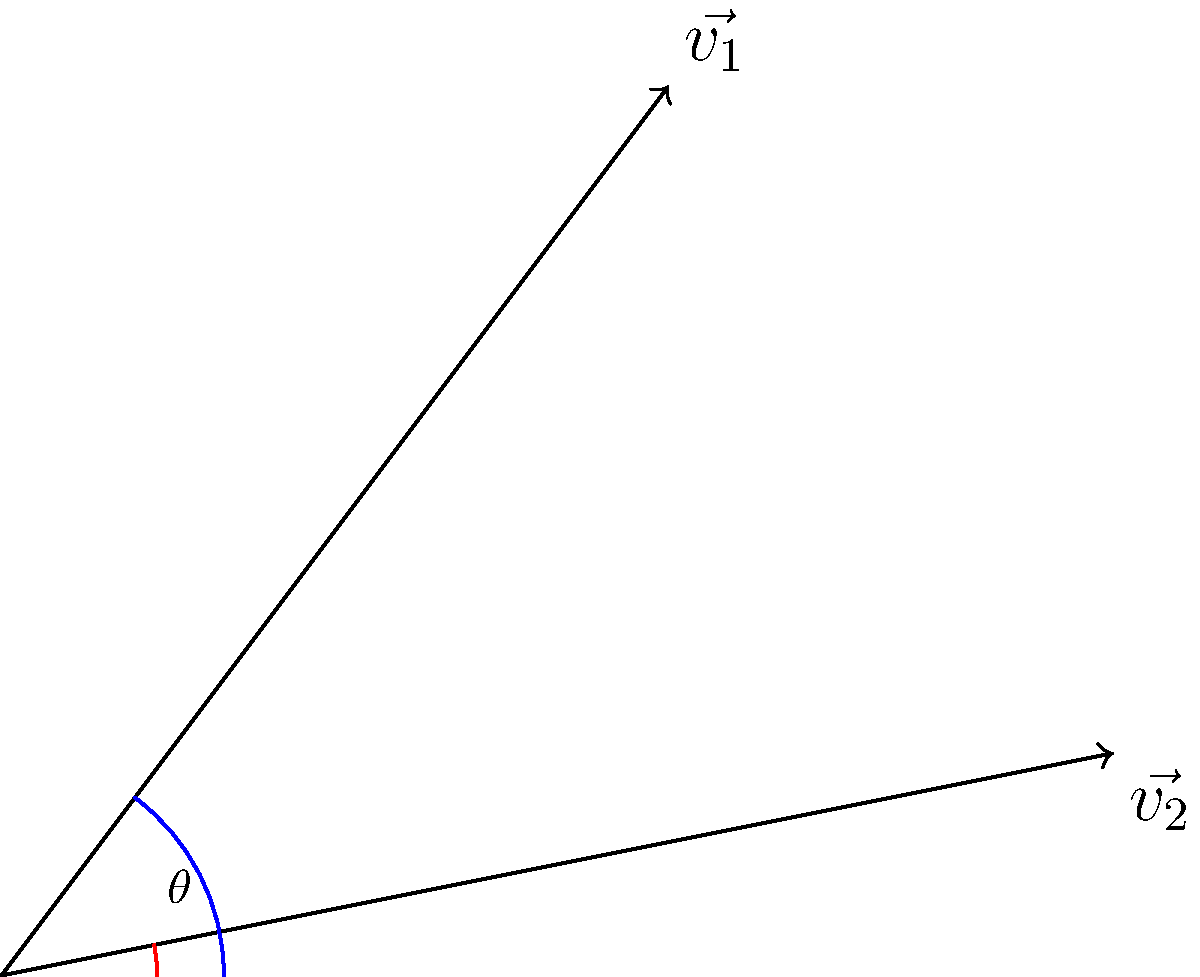Given two velocity vectors $\vec{v_1} = (3, 4)$ and $\vec{v_2} = (5, 1)$ in a 2D plane, determine the angle $\theta$ between them. Express your answer in degrees, rounded to the nearest whole number. To find the angle between two vectors, we can use the dot product formula:

1) The dot product formula: $\cos \theta = \frac{\vec{v_1} \cdot \vec{v_2}}{|\vec{v_1}||\vec{v_2}|}$

2) Calculate the dot product:
   $\vec{v_1} \cdot \vec{v_2} = (3 \times 5) + (4 \times 1) = 15 + 4 = 19$

3) Calculate the magnitudes:
   $|\vec{v_1}| = \sqrt{3^2 + 4^2} = \sqrt{9 + 16} = \sqrt{25} = 5$
   $|\vec{v_2}| = \sqrt{5^2 + 1^2} = \sqrt{25 + 1} = \sqrt{26}$

4) Substitute into the formula:
   $\cos \theta = \frac{19}{5\sqrt{26}}$

5) Take the inverse cosine (arccos) of both sides:
   $\theta = \arccos(\frac{19}{5\sqrt{26}})$

6) Convert to degrees and round to the nearest whole number:
   $\theta \approx 41.54^\circ \approx 42^\circ$
Answer: 42° 